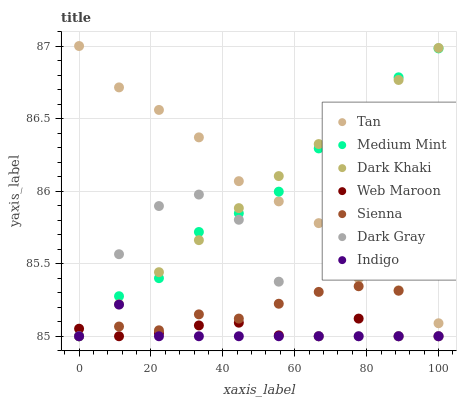Does Indigo have the minimum area under the curve?
Answer yes or no. Yes. Does Tan have the maximum area under the curve?
Answer yes or no. Yes. Does Dark Gray have the minimum area under the curve?
Answer yes or no. No. Does Dark Gray have the maximum area under the curve?
Answer yes or no. No. Is Dark Khaki the smoothest?
Answer yes or no. Yes. Is Dark Gray the roughest?
Answer yes or no. Yes. Is Indigo the smoothest?
Answer yes or no. No. Is Indigo the roughest?
Answer yes or no. No. Does Medium Mint have the lowest value?
Answer yes or no. Yes. Does Tan have the lowest value?
Answer yes or no. No. Does Tan have the highest value?
Answer yes or no. Yes. Does Dark Gray have the highest value?
Answer yes or no. No. Is Web Maroon less than Tan?
Answer yes or no. Yes. Is Tan greater than Dark Gray?
Answer yes or no. Yes. Does Sienna intersect Web Maroon?
Answer yes or no. Yes. Is Sienna less than Web Maroon?
Answer yes or no. No. Is Sienna greater than Web Maroon?
Answer yes or no. No. Does Web Maroon intersect Tan?
Answer yes or no. No. 